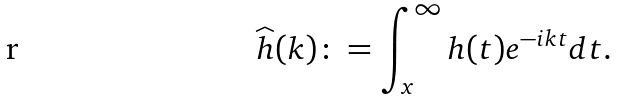<formula> <loc_0><loc_0><loc_500><loc_500>\widehat { h } ( k ) \colon = \int _ { x } ^ { \infty } h ( t ) e ^ { - i k t } d t .</formula> 